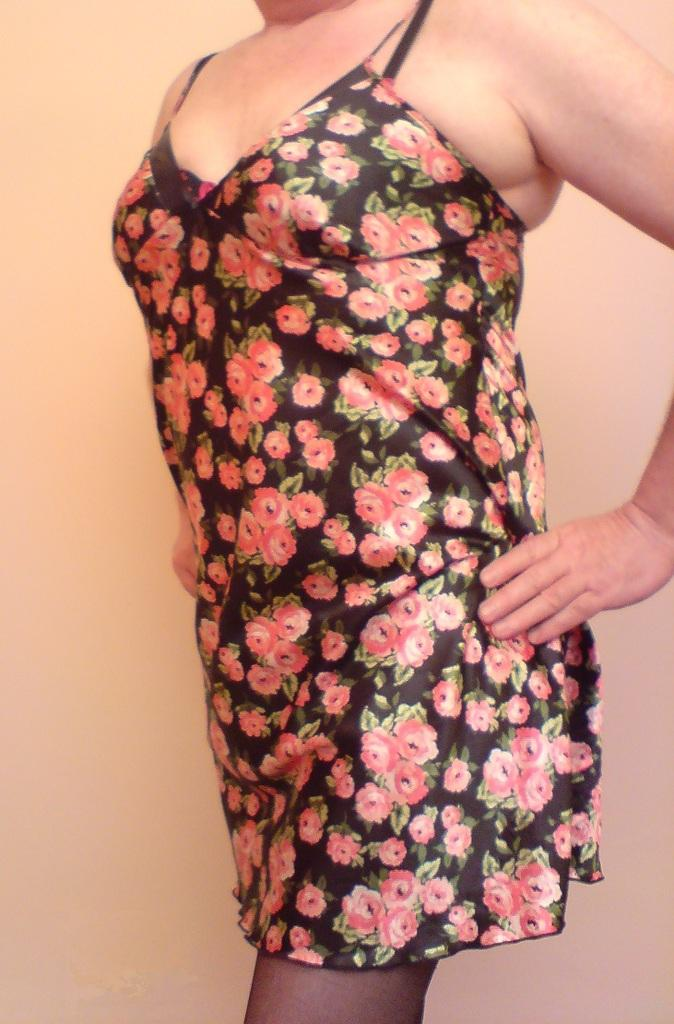What is the main subject of the image? There is a person in the image. Can you describe the background of the image? The background of the image is plain. How many points and circles can be seen on the person's hands in the image? There are no points or circles visible on the person's hands in the image. 